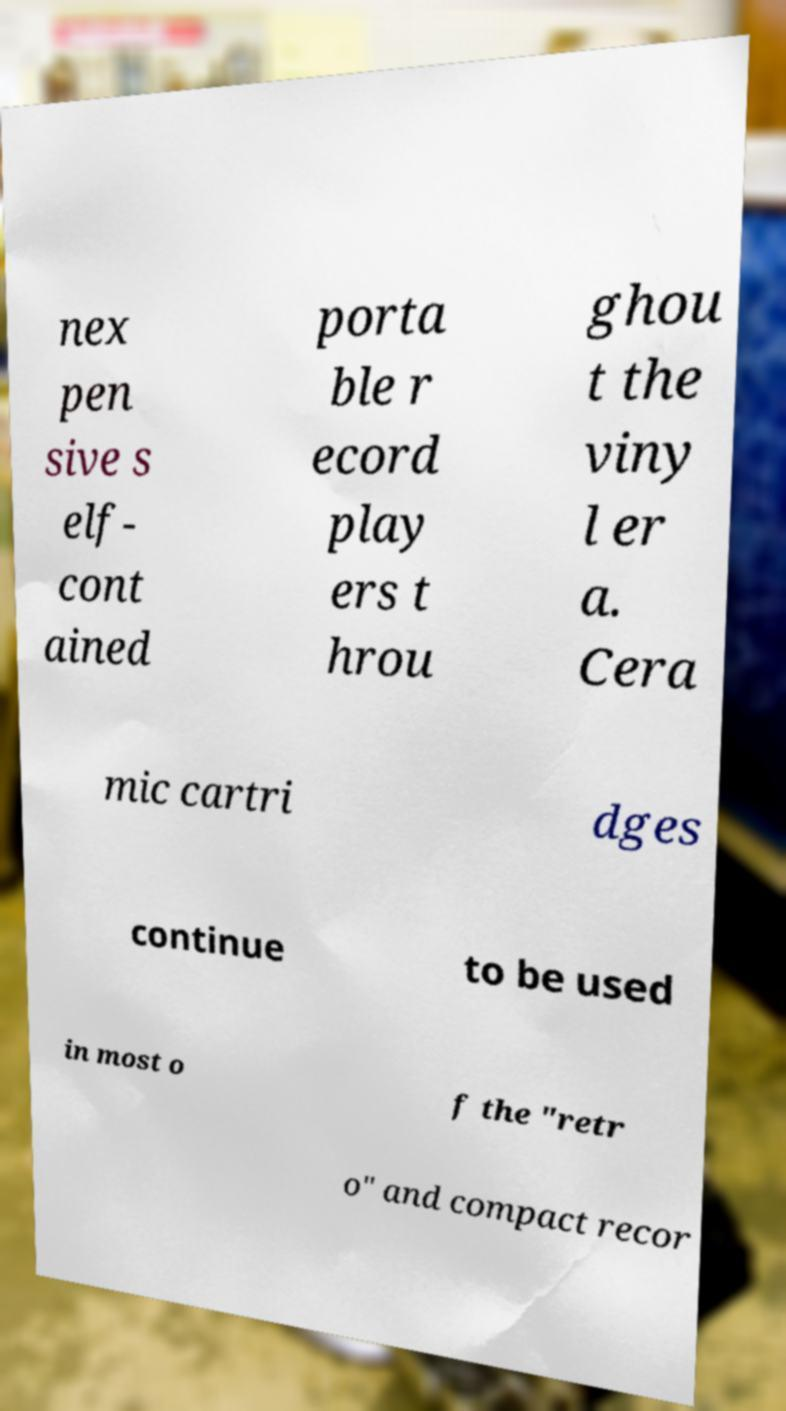I need the written content from this picture converted into text. Can you do that? nex pen sive s elf- cont ained porta ble r ecord play ers t hrou ghou t the viny l er a. Cera mic cartri dges continue to be used in most o f the "retr o" and compact recor 